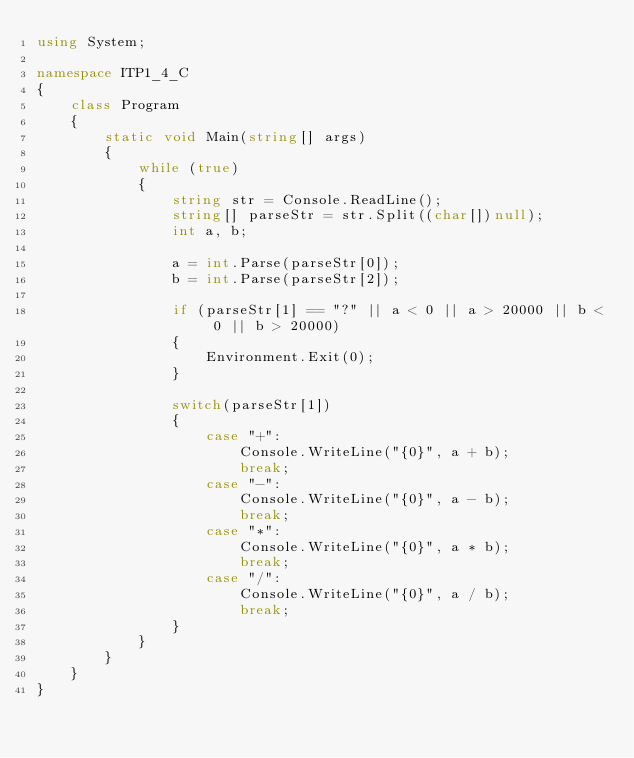<code> <loc_0><loc_0><loc_500><loc_500><_C#_>using System;

namespace ITP1_4_C
{
    class Program
    {
        static void Main(string[] args)
        {
            while (true)
            {
                string str = Console.ReadLine();
                string[] parseStr = str.Split((char[])null);
                int a, b;
            
                a = int.Parse(parseStr[0]);
                b = int.Parse(parseStr[2]);

                if (parseStr[1] == "?" || a < 0 || a > 20000 || b < 0 || b > 20000)
                {
                    Environment.Exit(0);
                }

                switch(parseStr[1])
                {
                    case "+":
                        Console.WriteLine("{0}", a + b);
                        break;
                    case "-":
                        Console.WriteLine("{0}", a - b);
                        break;
                    case "*":
                        Console.WriteLine("{0}", a * b);
                        break;
                    case "/":
                        Console.WriteLine("{0}", a / b);
                        break;
                }
            }
        }
    }
}
</code> 